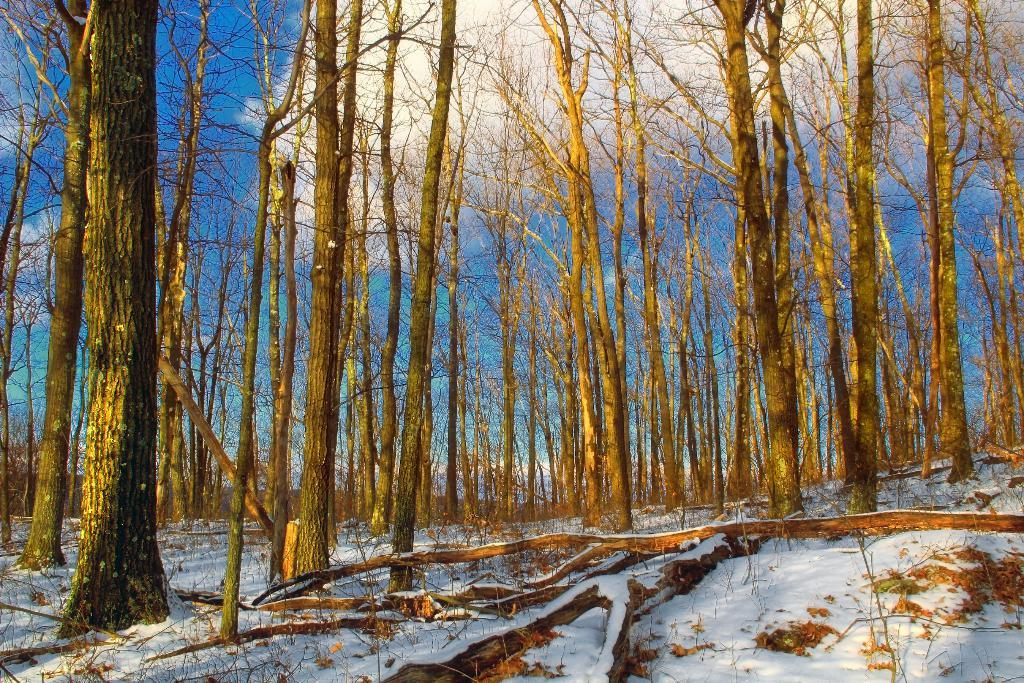What type of vegetation is present in the image? There are trees in the image. What is covering the ground at the bottom of the image? There is snow at the bottom of the image. What can be seen in the sky at the top of the image? There are clouds in the sky at the top of the image. Can you describe the twist in the snake's body in the image? There is no snake present in the image, so it is not possible to describe a twist in its body. 